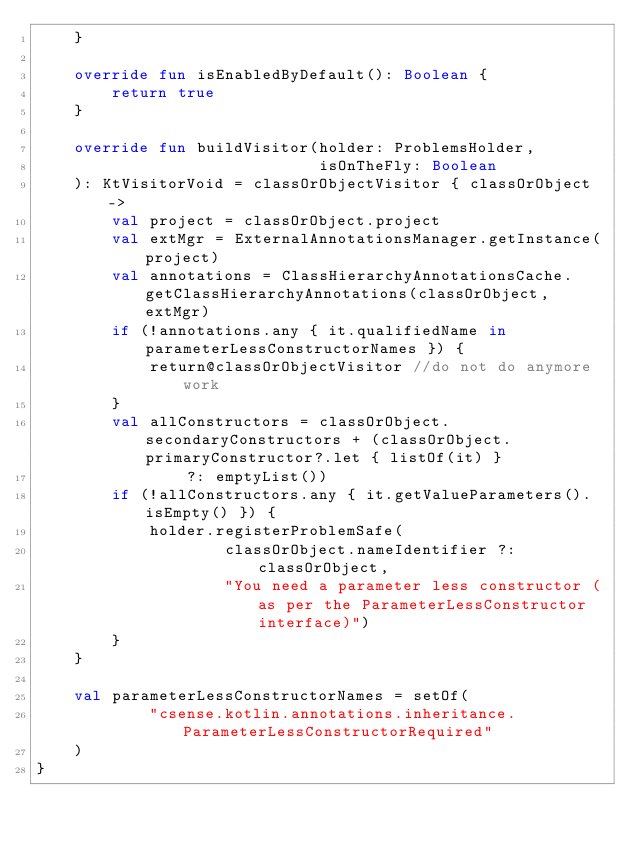Convert code to text. <code><loc_0><loc_0><loc_500><loc_500><_Kotlin_>    }
    
    override fun isEnabledByDefault(): Boolean {
        return true
    }
    
    override fun buildVisitor(holder: ProblemsHolder,
                              isOnTheFly: Boolean
    ): KtVisitorVoid = classOrObjectVisitor { classOrObject ->
        val project = classOrObject.project
        val extMgr = ExternalAnnotationsManager.getInstance(project)
        val annotations = ClassHierarchyAnnotationsCache.getClassHierarchyAnnotations(classOrObject, extMgr)
        if (!annotations.any { it.qualifiedName in parameterLessConstructorNames }) {
            return@classOrObjectVisitor //do not do anymore work
        }
        val allConstructors = classOrObject.secondaryConstructors + (classOrObject.primaryConstructor?.let { listOf(it) }
                ?: emptyList())
        if (!allConstructors.any { it.getValueParameters().isEmpty() }) {
            holder.registerProblemSafe(
                    classOrObject.nameIdentifier ?: classOrObject,
                    "You need a parameter less constructor (as per the ParameterLessConstructor interface)")
        }
    }
    
    val parameterLessConstructorNames = setOf(
            "csense.kotlin.annotations.inheritance.ParameterLessConstructorRequired"
    )
}</code> 